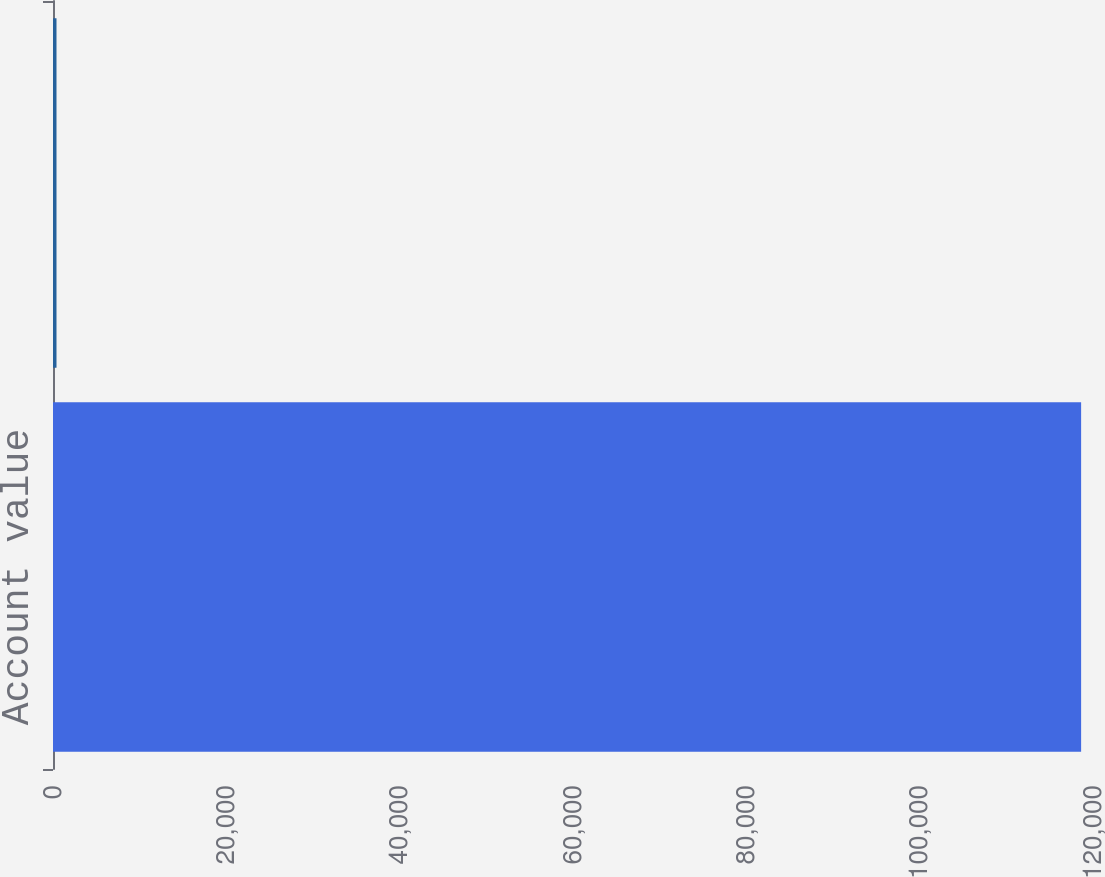Convert chart to OTSL. <chart><loc_0><loc_0><loc_500><loc_500><bar_chart><fcel>Account value<fcel>Net amount at risk<nl><fcel>118629<fcel>403<nl></chart> 